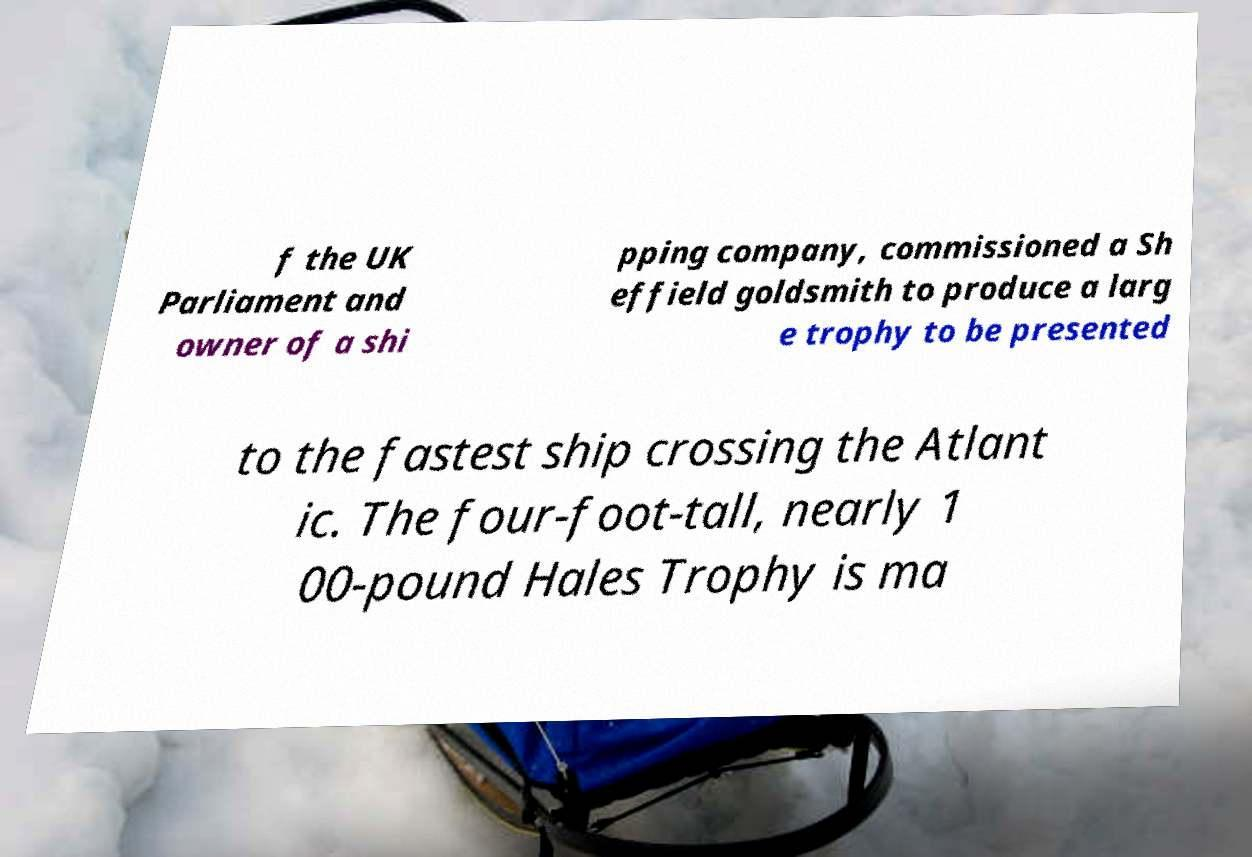Please read and relay the text visible in this image. What does it say? f the UK Parliament and owner of a shi pping company, commissioned a Sh effield goldsmith to produce a larg e trophy to be presented to the fastest ship crossing the Atlant ic. The four-foot-tall, nearly 1 00-pound Hales Trophy is ma 